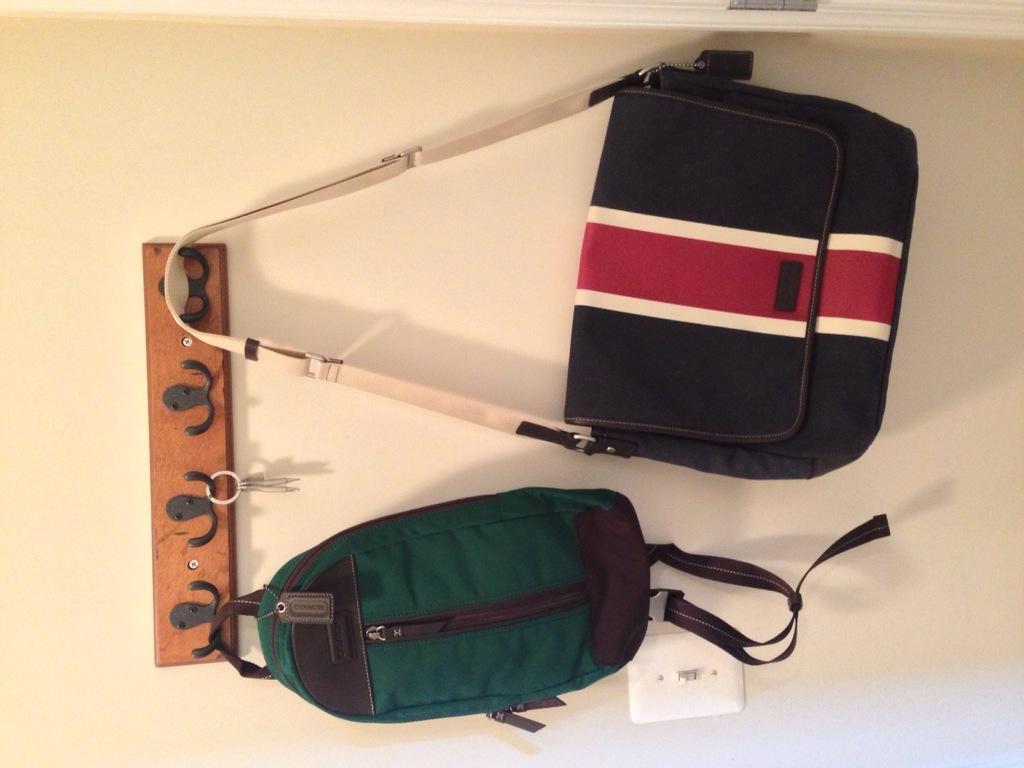Describe this image in one or two sentences. In this image in the middle there is a wall on that there is a stand with keys, backpack and handbag attached. 